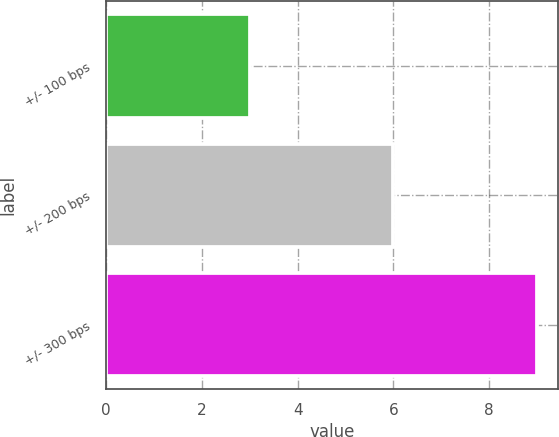<chart> <loc_0><loc_0><loc_500><loc_500><bar_chart><fcel>+/- 100 bps<fcel>+/- 200 bps<fcel>+/- 300 bps<nl><fcel>3<fcel>6<fcel>9<nl></chart> 